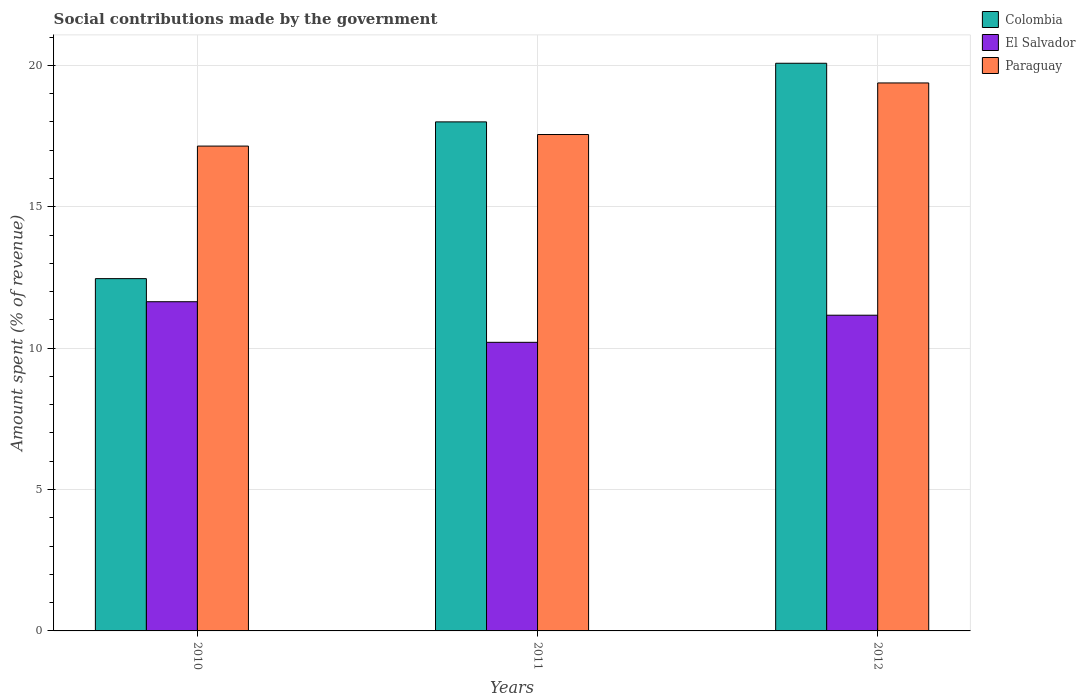Are the number of bars on each tick of the X-axis equal?
Give a very brief answer. Yes. How many bars are there on the 1st tick from the left?
Ensure brevity in your answer.  3. What is the amount spent (in %) on social contributions in Colombia in 2010?
Make the answer very short. 12.46. Across all years, what is the maximum amount spent (in %) on social contributions in El Salvador?
Offer a terse response. 11.64. Across all years, what is the minimum amount spent (in %) on social contributions in Paraguay?
Your answer should be compact. 17.15. In which year was the amount spent (in %) on social contributions in Paraguay maximum?
Make the answer very short. 2012. What is the total amount spent (in %) on social contributions in Paraguay in the graph?
Your response must be concise. 54.08. What is the difference between the amount spent (in %) on social contributions in Colombia in 2010 and that in 2011?
Give a very brief answer. -5.54. What is the difference between the amount spent (in %) on social contributions in Paraguay in 2011 and the amount spent (in %) on social contributions in El Salvador in 2010?
Make the answer very short. 5.91. What is the average amount spent (in %) on social contributions in El Salvador per year?
Keep it short and to the point. 11. In the year 2011, what is the difference between the amount spent (in %) on social contributions in Colombia and amount spent (in %) on social contributions in Paraguay?
Provide a short and direct response. 0.45. What is the ratio of the amount spent (in %) on social contributions in El Salvador in 2010 to that in 2011?
Give a very brief answer. 1.14. Is the amount spent (in %) on social contributions in El Salvador in 2010 less than that in 2011?
Offer a terse response. No. Is the difference between the amount spent (in %) on social contributions in Colombia in 2010 and 2011 greater than the difference between the amount spent (in %) on social contributions in Paraguay in 2010 and 2011?
Keep it short and to the point. No. What is the difference between the highest and the second highest amount spent (in %) on social contributions in El Salvador?
Offer a terse response. 0.48. What is the difference between the highest and the lowest amount spent (in %) on social contributions in Colombia?
Your response must be concise. 7.62. In how many years, is the amount spent (in %) on social contributions in Paraguay greater than the average amount spent (in %) on social contributions in Paraguay taken over all years?
Your response must be concise. 1. What does the 2nd bar from the left in 2011 represents?
Provide a succinct answer. El Salvador. What does the 1st bar from the right in 2011 represents?
Offer a terse response. Paraguay. Is it the case that in every year, the sum of the amount spent (in %) on social contributions in El Salvador and amount spent (in %) on social contributions in Paraguay is greater than the amount spent (in %) on social contributions in Colombia?
Give a very brief answer. Yes. How many bars are there?
Your answer should be compact. 9. Are all the bars in the graph horizontal?
Provide a succinct answer. No. Does the graph contain any zero values?
Keep it short and to the point. No. Where does the legend appear in the graph?
Ensure brevity in your answer.  Top right. What is the title of the graph?
Provide a short and direct response. Social contributions made by the government. What is the label or title of the X-axis?
Give a very brief answer. Years. What is the label or title of the Y-axis?
Offer a very short reply. Amount spent (% of revenue). What is the Amount spent (% of revenue) in Colombia in 2010?
Give a very brief answer. 12.46. What is the Amount spent (% of revenue) in El Salvador in 2010?
Provide a succinct answer. 11.64. What is the Amount spent (% of revenue) in Paraguay in 2010?
Offer a terse response. 17.15. What is the Amount spent (% of revenue) in Colombia in 2011?
Provide a short and direct response. 18. What is the Amount spent (% of revenue) in El Salvador in 2011?
Provide a short and direct response. 10.21. What is the Amount spent (% of revenue) in Paraguay in 2011?
Your answer should be compact. 17.55. What is the Amount spent (% of revenue) in Colombia in 2012?
Give a very brief answer. 20.08. What is the Amount spent (% of revenue) of El Salvador in 2012?
Make the answer very short. 11.16. What is the Amount spent (% of revenue) in Paraguay in 2012?
Make the answer very short. 19.38. Across all years, what is the maximum Amount spent (% of revenue) in Colombia?
Ensure brevity in your answer.  20.08. Across all years, what is the maximum Amount spent (% of revenue) in El Salvador?
Give a very brief answer. 11.64. Across all years, what is the maximum Amount spent (% of revenue) of Paraguay?
Provide a short and direct response. 19.38. Across all years, what is the minimum Amount spent (% of revenue) in Colombia?
Your response must be concise. 12.46. Across all years, what is the minimum Amount spent (% of revenue) of El Salvador?
Your answer should be very brief. 10.21. Across all years, what is the minimum Amount spent (% of revenue) of Paraguay?
Offer a terse response. 17.15. What is the total Amount spent (% of revenue) in Colombia in the graph?
Provide a succinct answer. 50.54. What is the total Amount spent (% of revenue) of El Salvador in the graph?
Your response must be concise. 33.01. What is the total Amount spent (% of revenue) in Paraguay in the graph?
Your answer should be compact. 54.08. What is the difference between the Amount spent (% of revenue) in Colombia in 2010 and that in 2011?
Your response must be concise. -5.54. What is the difference between the Amount spent (% of revenue) in El Salvador in 2010 and that in 2011?
Provide a short and direct response. 1.44. What is the difference between the Amount spent (% of revenue) in Paraguay in 2010 and that in 2011?
Offer a terse response. -0.41. What is the difference between the Amount spent (% of revenue) in Colombia in 2010 and that in 2012?
Ensure brevity in your answer.  -7.62. What is the difference between the Amount spent (% of revenue) in El Salvador in 2010 and that in 2012?
Your answer should be very brief. 0.48. What is the difference between the Amount spent (% of revenue) of Paraguay in 2010 and that in 2012?
Ensure brevity in your answer.  -2.23. What is the difference between the Amount spent (% of revenue) in Colombia in 2011 and that in 2012?
Your answer should be compact. -2.07. What is the difference between the Amount spent (% of revenue) of El Salvador in 2011 and that in 2012?
Keep it short and to the point. -0.96. What is the difference between the Amount spent (% of revenue) in Paraguay in 2011 and that in 2012?
Provide a succinct answer. -1.82. What is the difference between the Amount spent (% of revenue) of Colombia in 2010 and the Amount spent (% of revenue) of El Salvador in 2011?
Ensure brevity in your answer.  2.25. What is the difference between the Amount spent (% of revenue) of Colombia in 2010 and the Amount spent (% of revenue) of Paraguay in 2011?
Your response must be concise. -5.1. What is the difference between the Amount spent (% of revenue) of El Salvador in 2010 and the Amount spent (% of revenue) of Paraguay in 2011?
Provide a succinct answer. -5.91. What is the difference between the Amount spent (% of revenue) in Colombia in 2010 and the Amount spent (% of revenue) in El Salvador in 2012?
Your response must be concise. 1.29. What is the difference between the Amount spent (% of revenue) in Colombia in 2010 and the Amount spent (% of revenue) in Paraguay in 2012?
Your answer should be very brief. -6.92. What is the difference between the Amount spent (% of revenue) of El Salvador in 2010 and the Amount spent (% of revenue) of Paraguay in 2012?
Ensure brevity in your answer.  -7.74. What is the difference between the Amount spent (% of revenue) of Colombia in 2011 and the Amount spent (% of revenue) of El Salvador in 2012?
Keep it short and to the point. 6.84. What is the difference between the Amount spent (% of revenue) in Colombia in 2011 and the Amount spent (% of revenue) in Paraguay in 2012?
Provide a succinct answer. -1.38. What is the difference between the Amount spent (% of revenue) in El Salvador in 2011 and the Amount spent (% of revenue) in Paraguay in 2012?
Keep it short and to the point. -9.17. What is the average Amount spent (% of revenue) of Colombia per year?
Offer a terse response. 16.85. What is the average Amount spent (% of revenue) in El Salvador per year?
Make the answer very short. 11. What is the average Amount spent (% of revenue) of Paraguay per year?
Your answer should be compact. 18.03. In the year 2010, what is the difference between the Amount spent (% of revenue) of Colombia and Amount spent (% of revenue) of El Salvador?
Ensure brevity in your answer.  0.82. In the year 2010, what is the difference between the Amount spent (% of revenue) in Colombia and Amount spent (% of revenue) in Paraguay?
Your answer should be compact. -4.69. In the year 2010, what is the difference between the Amount spent (% of revenue) in El Salvador and Amount spent (% of revenue) in Paraguay?
Offer a terse response. -5.5. In the year 2011, what is the difference between the Amount spent (% of revenue) of Colombia and Amount spent (% of revenue) of El Salvador?
Ensure brevity in your answer.  7.8. In the year 2011, what is the difference between the Amount spent (% of revenue) in Colombia and Amount spent (% of revenue) in Paraguay?
Offer a terse response. 0.45. In the year 2011, what is the difference between the Amount spent (% of revenue) in El Salvador and Amount spent (% of revenue) in Paraguay?
Your answer should be compact. -7.35. In the year 2012, what is the difference between the Amount spent (% of revenue) of Colombia and Amount spent (% of revenue) of El Salvador?
Make the answer very short. 8.91. In the year 2012, what is the difference between the Amount spent (% of revenue) of Colombia and Amount spent (% of revenue) of Paraguay?
Ensure brevity in your answer.  0.7. In the year 2012, what is the difference between the Amount spent (% of revenue) in El Salvador and Amount spent (% of revenue) in Paraguay?
Offer a terse response. -8.21. What is the ratio of the Amount spent (% of revenue) of Colombia in 2010 to that in 2011?
Ensure brevity in your answer.  0.69. What is the ratio of the Amount spent (% of revenue) of El Salvador in 2010 to that in 2011?
Provide a short and direct response. 1.14. What is the ratio of the Amount spent (% of revenue) in Paraguay in 2010 to that in 2011?
Provide a succinct answer. 0.98. What is the ratio of the Amount spent (% of revenue) in Colombia in 2010 to that in 2012?
Make the answer very short. 0.62. What is the ratio of the Amount spent (% of revenue) of El Salvador in 2010 to that in 2012?
Provide a succinct answer. 1.04. What is the ratio of the Amount spent (% of revenue) of Paraguay in 2010 to that in 2012?
Make the answer very short. 0.88. What is the ratio of the Amount spent (% of revenue) of Colombia in 2011 to that in 2012?
Your response must be concise. 0.9. What is the ratio of the Amount spent (% of revenue) in El Salvador in 2011 to that in 2012?
Make the answer very short. 0.91. What is the ratio of the Amount spent (% of revenue) in Paraguay in 2011 to that in 2012?
Offer a very short reply. 0.91. What is the difference between the highest and the second highest Amount spent (% of revenue) in Colombia?
Offer a terse response. 2.07. What is the difference between the highest and the second highest Amount spent (% of revenue) in El Salvador?
Offer a very short reply. 0.48. What is the difference between the highest and the second highest Amount spent (% of revenue) of Paraguay?
Make the answer very short. 1.82. What is the difference between the highest and the lowest Amount spent (% of revenue) in Colombia?
Provide a succinct answer. 7.62. What is the difference between the highest and the lowest Amount spent (% of revenue) of El Salvador?
Give a very brief answer. 1.44. What is the difference between the highest and the lowest Amount spent (% of revenue) of Paraguay?
Provide a short and direct response. 2.23. 